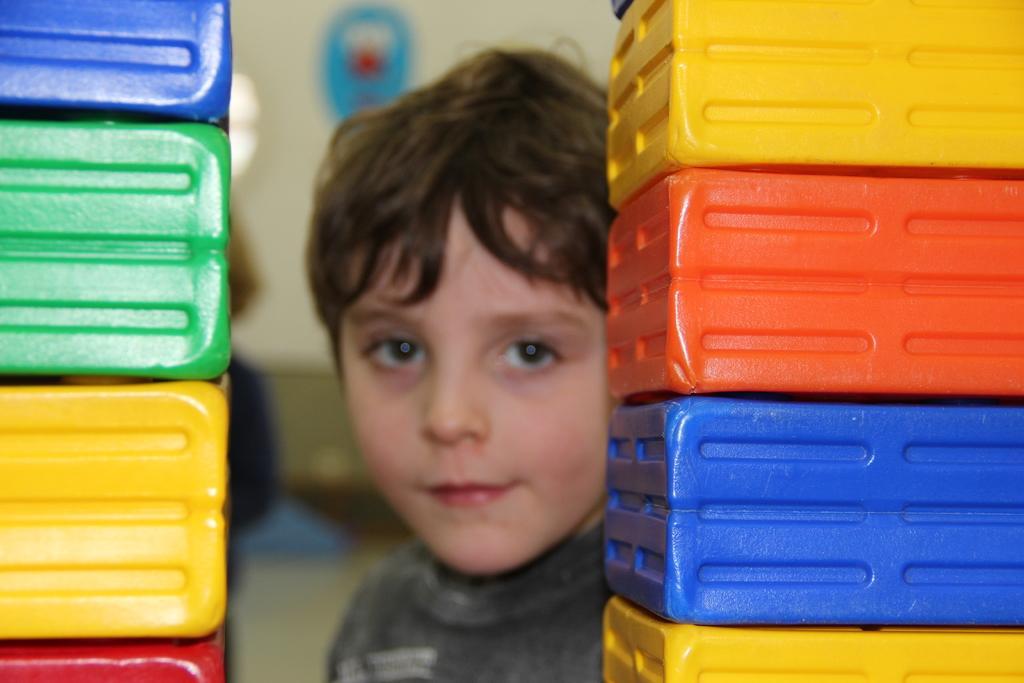Please provide a concise description of this image. In the image there are few plastic boxes arranged one upon another and there is a boy behind those boxes. 